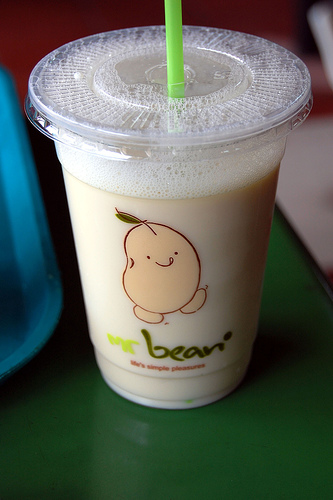<image>
Is there a bean in front of the straw? Yes. The bean is positioned in front of the straw, appearing closer to the camera viewpoint. 